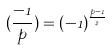Convert formula to latex. <formula><loc_0><loc_0><loc_500><loc_500>( \frac { - 1 } { p } ) = ( - 1 ) ^ { \frac { p - 1 } { 2 } }</formula> 